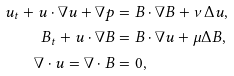<formula> <loc_0><loc_0><loc_500><loc_500>u _ { t } + u \cdot \nabla u + \nabla p & = B \cdot \nabla B + \nu \Delta u , \\ B _ { t } + u \cdot \nabla B & = B \cdot \nabla u + \mu \Delta B , \\ \nabla \cdot u = \nabla \cdot B & = 0 ,</formula> 